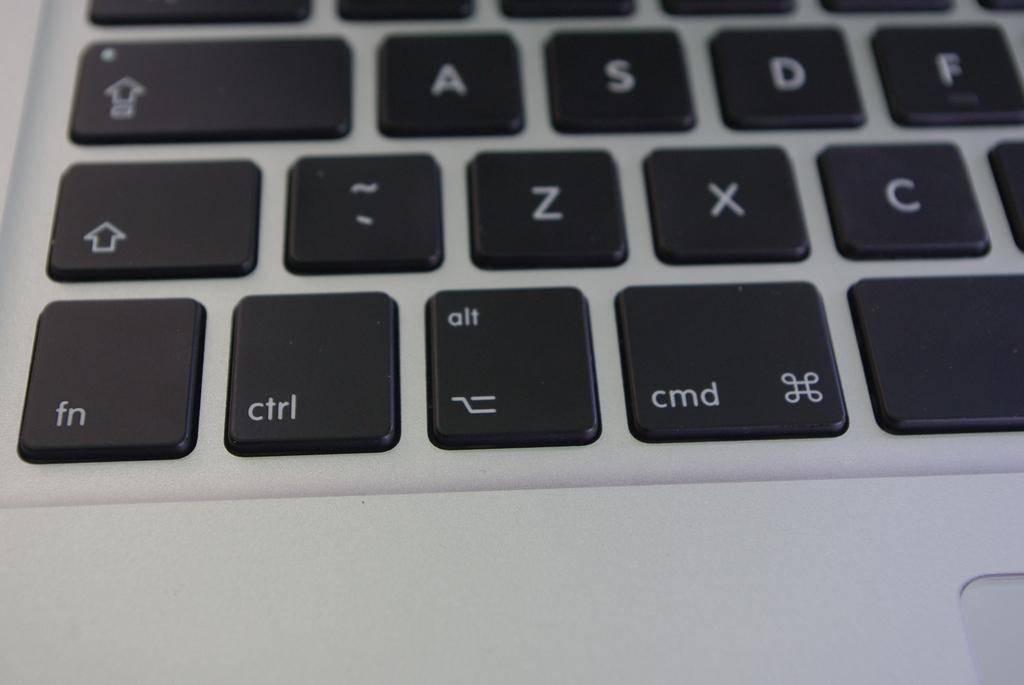<image>
Present a compact description of the photo's key features. a close up of a keyboard with the key fn at the bottom left 